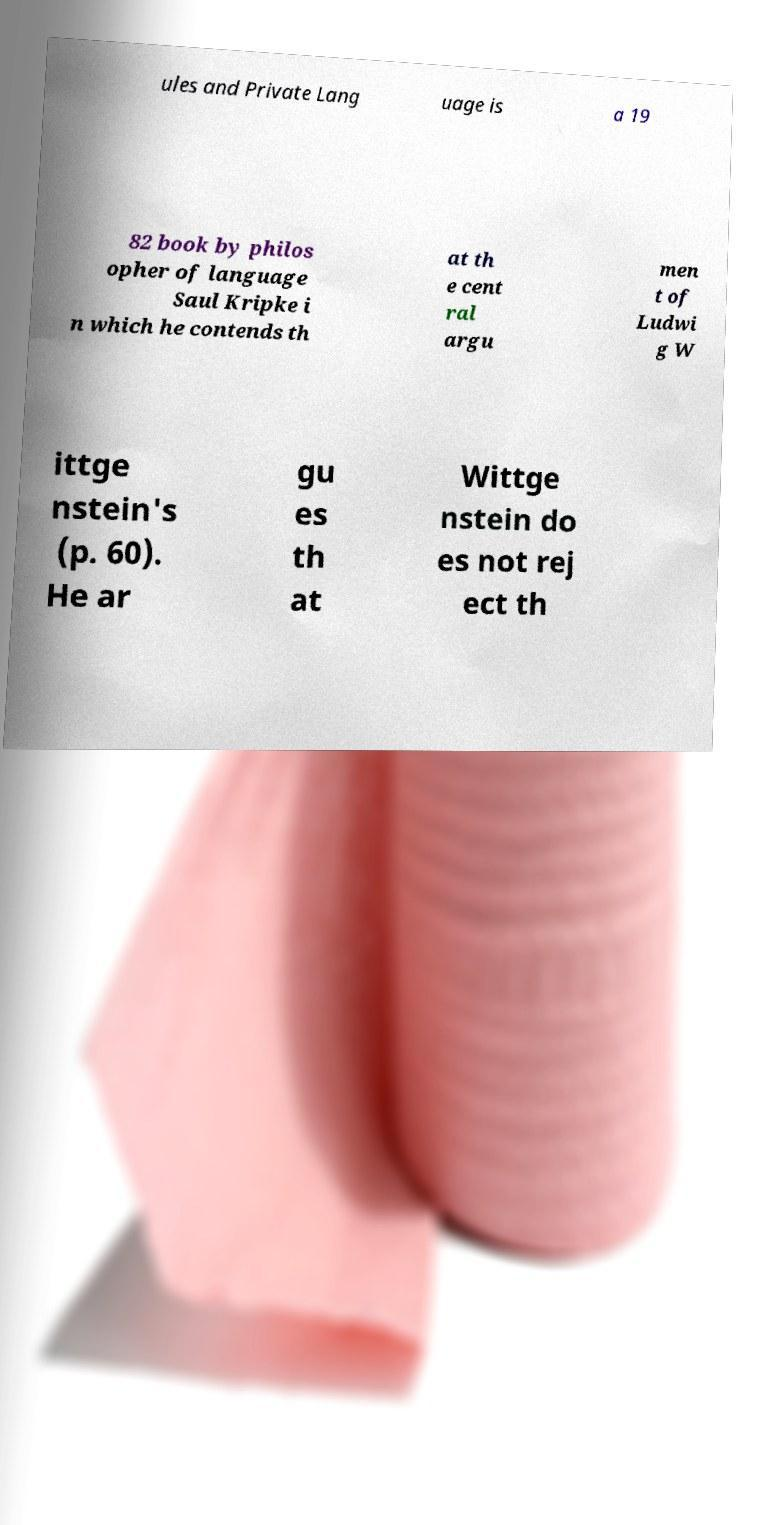There's text embedded in this image that I need extracted. Can you transcribe it verbatim? ules and Private Lang uage is a 19 82 book by philos opher of language Saul Kripke i n which he contends th at th e cent ral argu men t of Ludwi g W ittge nstein's (p. 60). He ar gu es th at Wittge nstein do es not rej ect th 